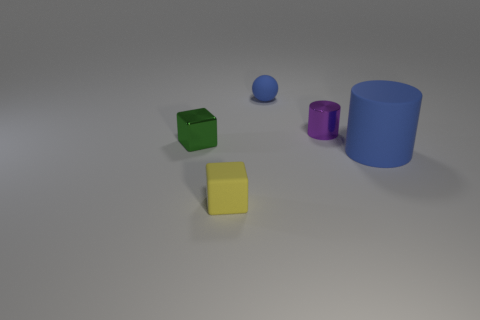Do the purple cylinder and the matte object that is behind the green thing have the same size?
Your answer should be very brief. Yes. What number of other things are the same shape as the small blue thing?
Offer a terse response. 0. What is the shape of the large blue object that is made of the same material as the tiny yellow cube?
Ensure brevity in your answer.  Cylinder. Is there a big brown matte cylinder?
Give a very brief answer. No. Are there fewer blocks that are right of the small yellow cube than blue rubber things right of the small blue matte sphere?
Offer a terse response. Yes. The small metal object that is on the right side of the small yellow matte cube has what shape?
Your answer should be compact. Cylinder. Is the material of the ball the same as the large blue thing?
Offer a very short reply. Yes. There is a tiny thing that is the same shape as the big blue thing; what is its material?
Offer a very short reply. Metal. Is the number of blue balls that are in front of the tiny yellow cube less than the number of tiny purple things?
Give a very brief answer. Yes. How many tiny yellow matte blocks are right of the tiny green metallic block?
Give a very brief answer. 1. 